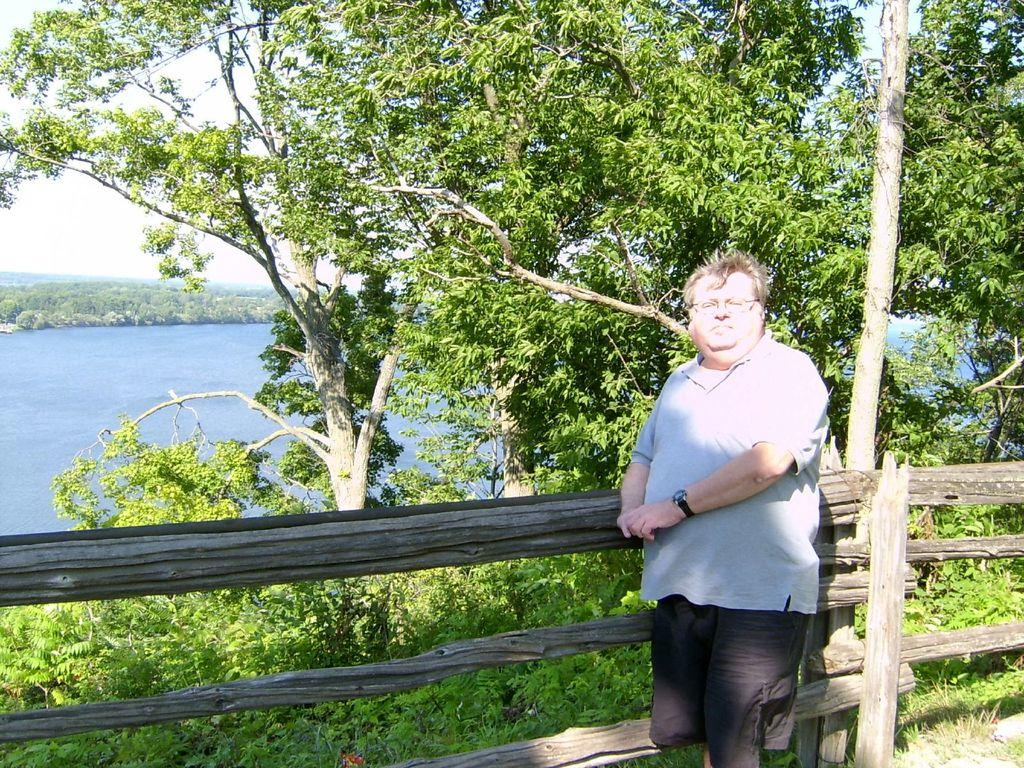Who or what is located in the front of the image? There is a person in the front of the image. What can be seen in the front of the image besides the person? There is a wooden railing and trees in the front of the image. What is visible in the background of the image? The sky, greenery, and water are visible in the background of the image. What type of religious bell can be seen hanging from the trees in the image? There is no religious bell present in the image; it features a person, a wooden railing, trees, and a background with sky, greenery, and water. 